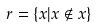<formula> <loc_0><loc_0><loc_500><loc_500>r = \{ x | x \notin x \}</formula> 